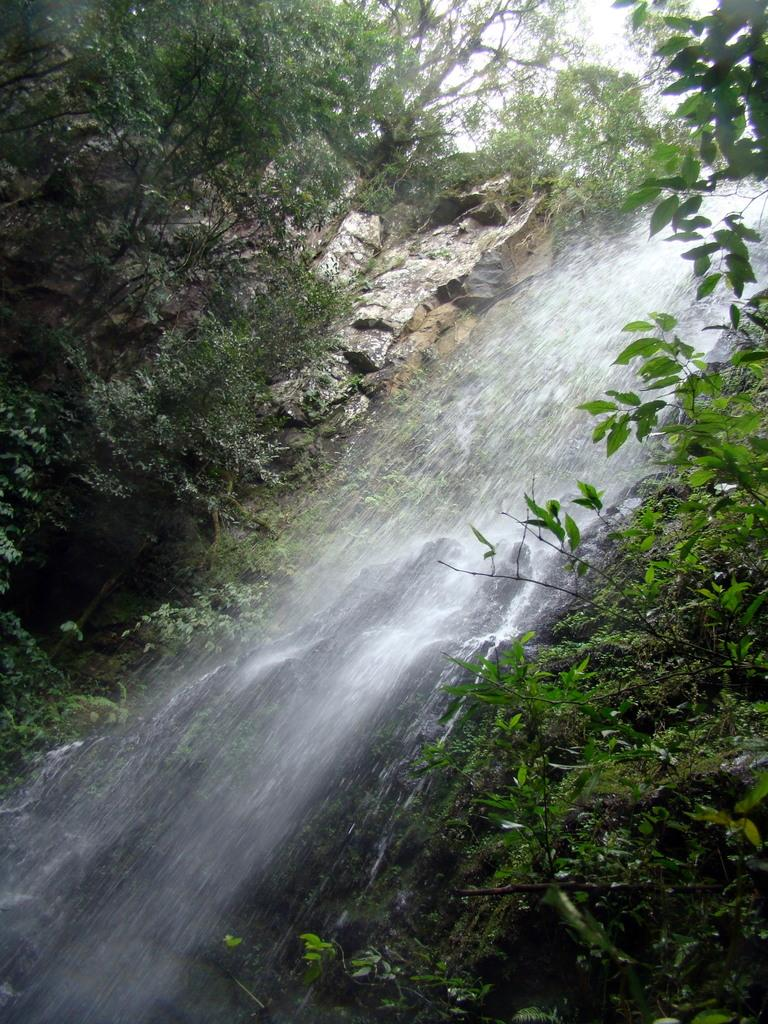What natural feature is the main subject of the image? There is a waterfall in the image. What other elements can be seen in the image? There are rocks and trees in the image. What is the color of the leaves on the trees? The leaves on the trees are green. What type of apparel is being worn by the waterfall in the image? There is no apparel present in the image, as the main subject is a natural waterfall. Can you describe the waves in the waterfall? There are no waves mentioned in the image; it features a waterfall with rocks and trees. 